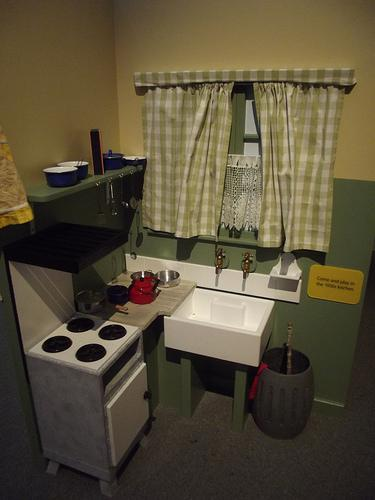Question: when will the kitchen be used?
Choices:
A. Daytime.
B. When people are hungry.
C. When the electricity is on.
D. When it is dinner time.
Answer with the letter. Answer: A Question: how big is this kitchen?
Choices:
A. Small.
B. Very large.
C. Big enough for a couple people to fit snuggly.
D. Just big enough for the appliances.
Answer with the letter. Answer: A Question: what is on the shelf?
Choices:
A. Books.
B. Dust.
C. A vase.
D. Dishes.
Answer with the letter. Answer: D Question: what color is the sign?
Choices:
A. White.
B. Red.
C. Orange.
D. Yellow.
Answer with the letter. Answer: D 